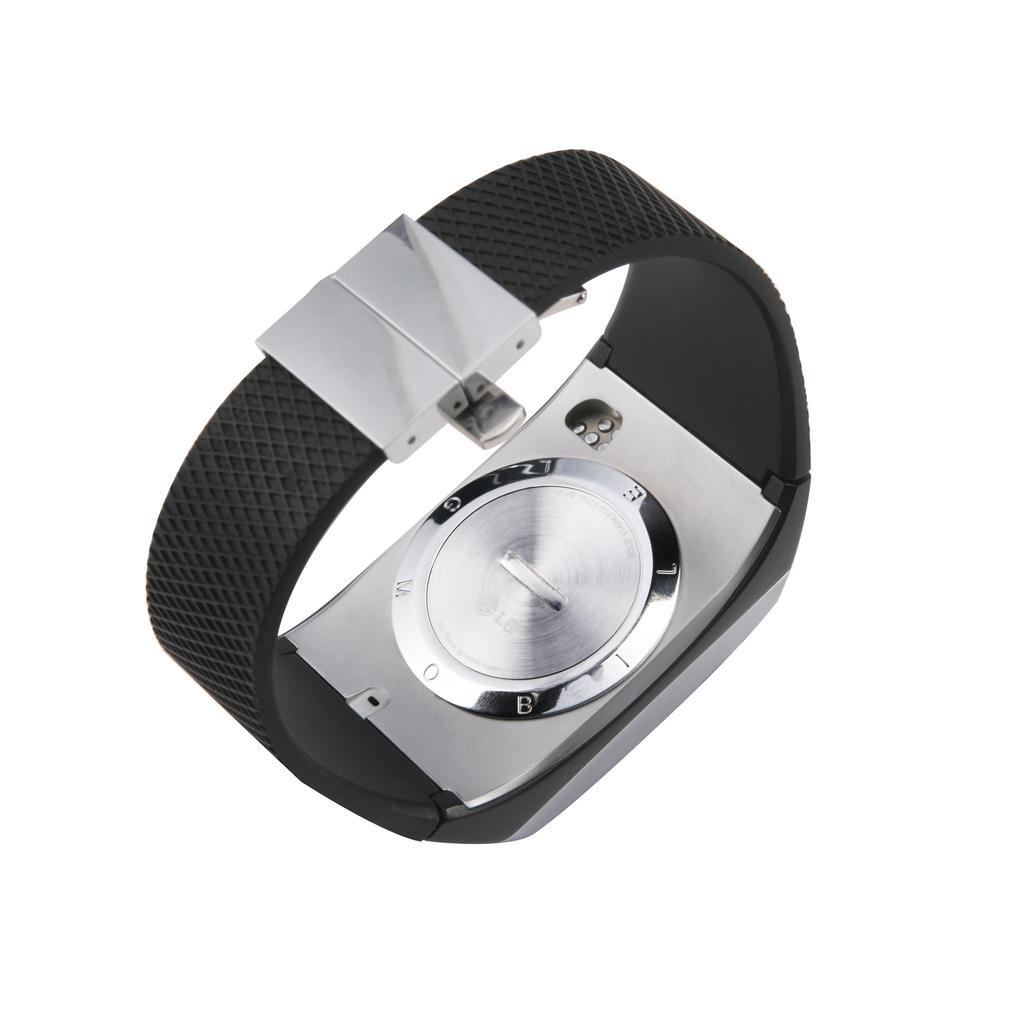Please provide a concise description of this image. In this image, I can see a wrist watch. This is the strap, which is black and color. This looks like a case cover. The background looks white in color. 